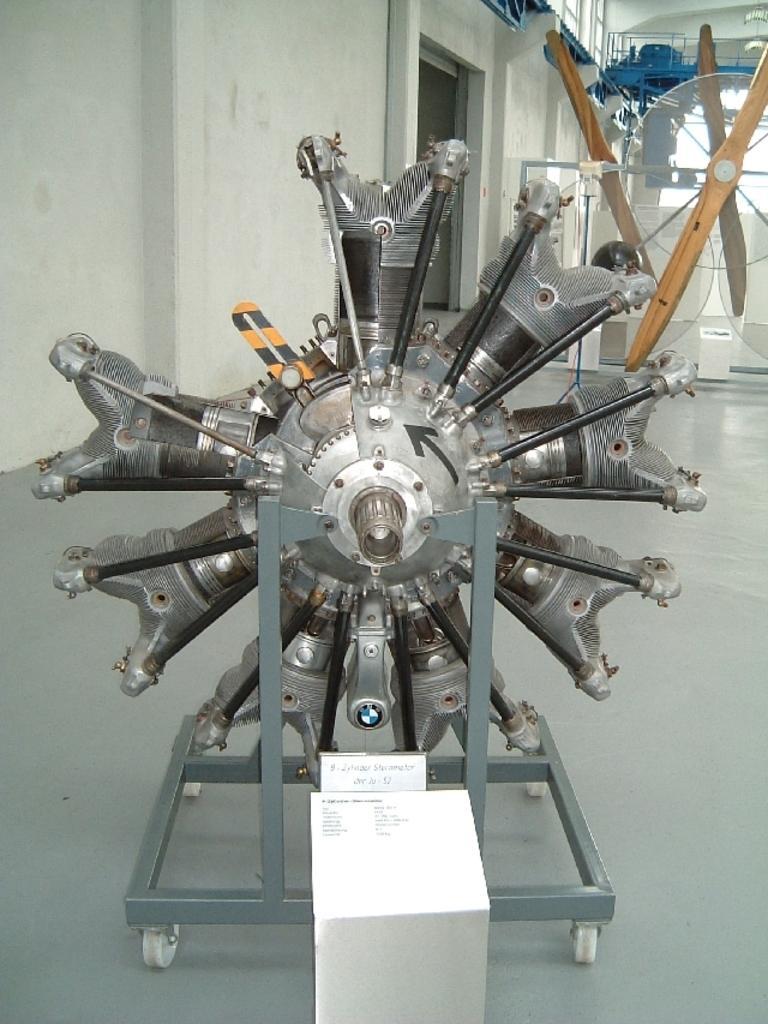Could you give a brief overview of what you see in this image? In this image in the foreground there is some metal object, and in the background there are some other objects, poles, wall. And at the bottom there is floor and there is a board. 